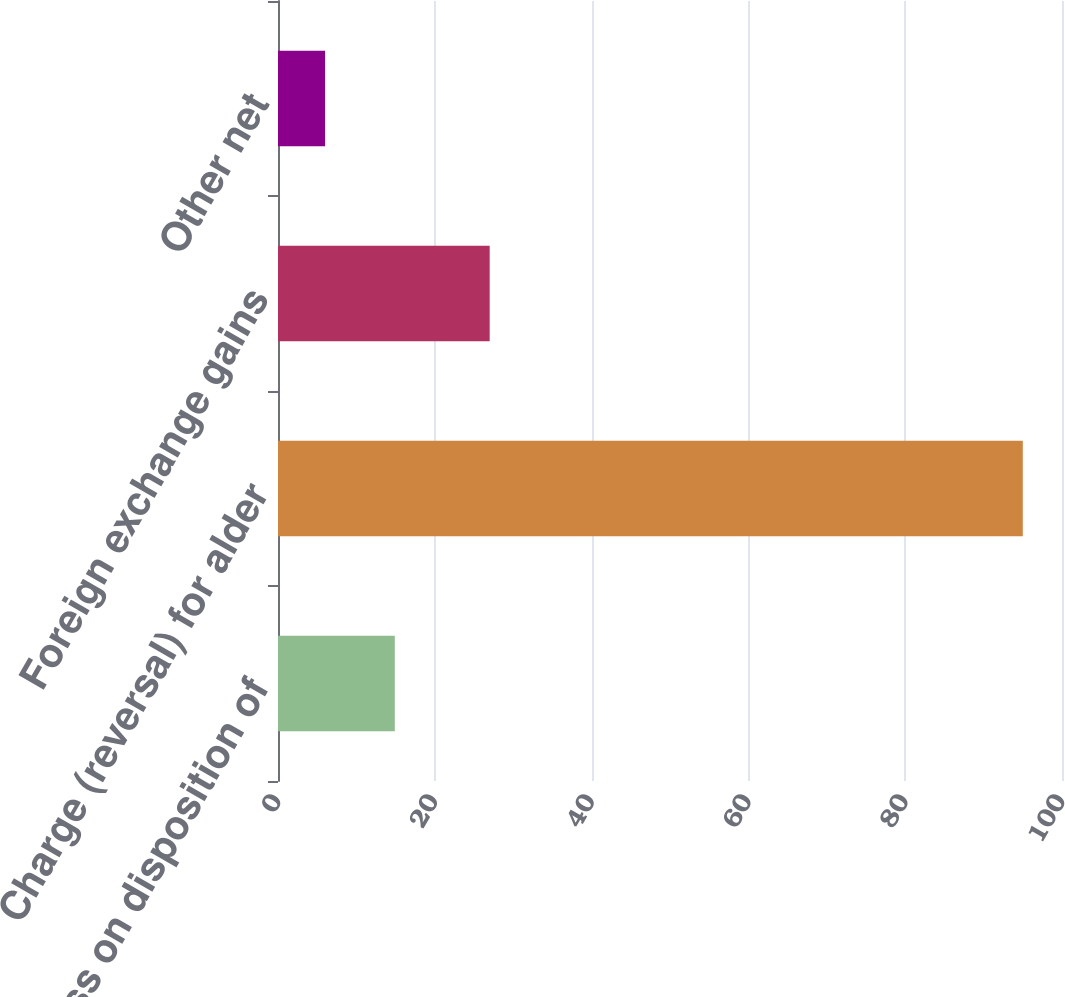<chart> <loc_0><loc_0><loc_500><loc_500><bar_chart><fcel>(Gain) loss on disposition of<fcel>Charge (reversal) for alder<fcel>Foreign exchange gains<fcel>Other net<nl><fcel>14.9<fcel>95<fcel>27<fcel>6<nl></chart> 